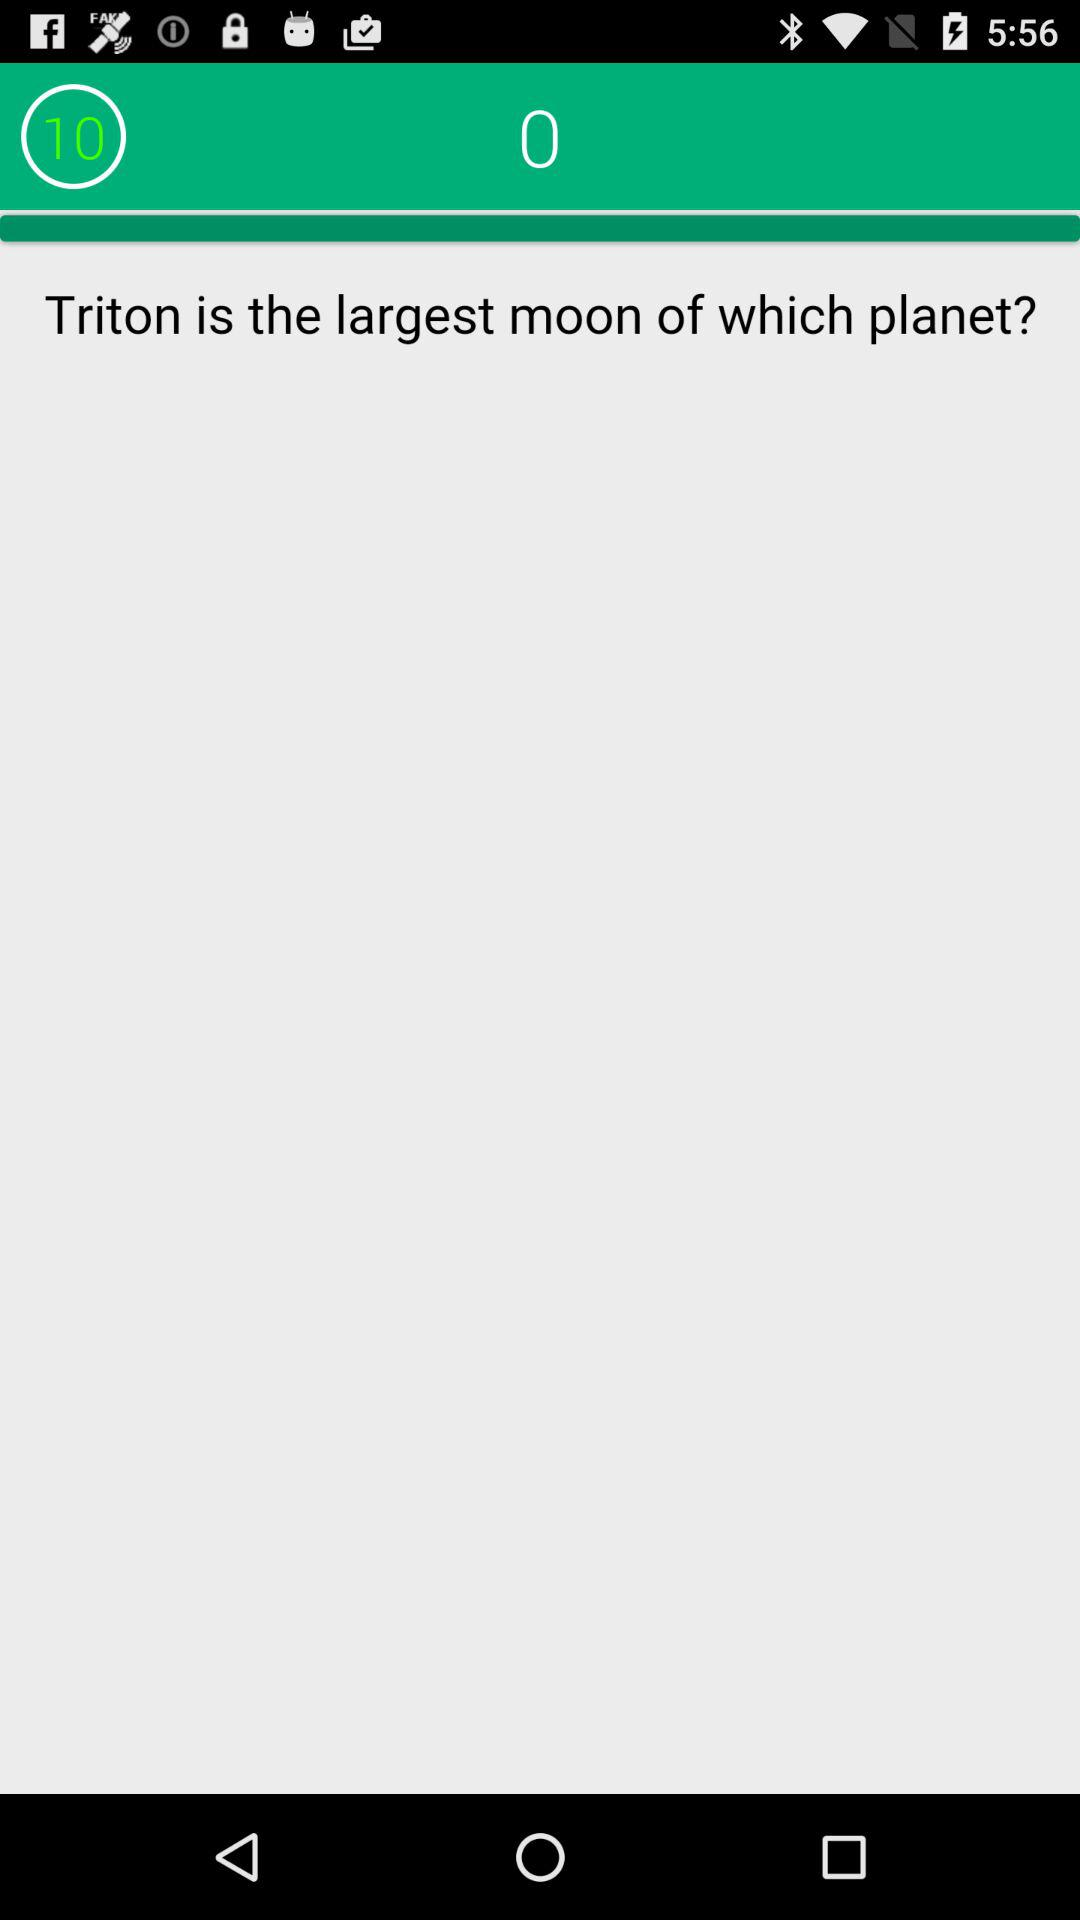What is the name of the mentioned largest moon? The name of the mentioned largest moon is Triton. 